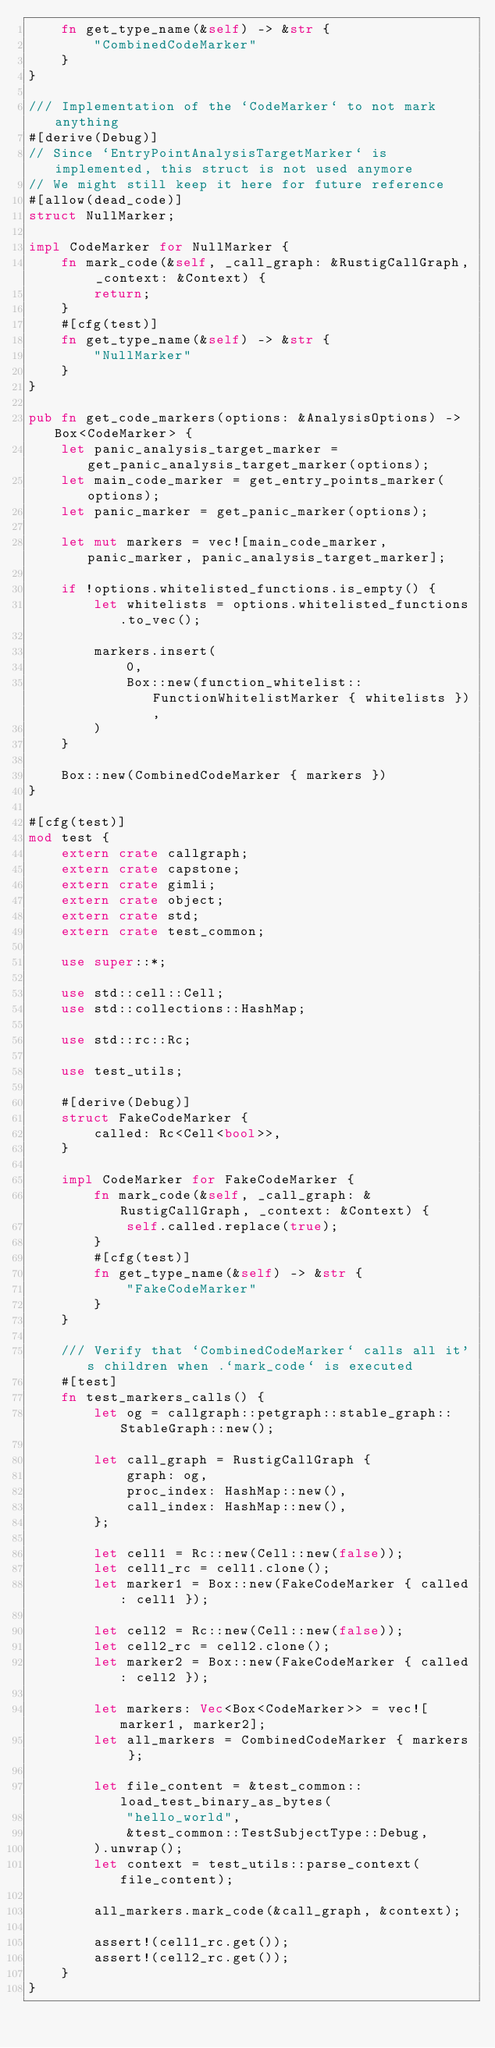<code> <loc_0><loc_0><loc_500><loc_500><_Rust_>    fn get_type_name(&self) -> &str {
        "CombinedCodeMarker"
    }
}

/// Implementation of the `CodeMarker` to not mark anything
#[derive(Debug)]
// Since `EntryPointAnalysisTargetMarker` is implemented, this struct is not used anymore
// We might still keep it here for future reference
#[allow(dead_code)]
struct NullMarker;

impl CodeMarker for NullMarker {
    fn mark_code(&self, _call_graph: &RustigCallGraph, _context: &Context) {
        return;
    }
    #[cfg(test)]
    fn get_type_name(&self) -> &str {
        "NullMarker"
    }
}

pub fn get_code_markers(options: &AnalysisOptions) -> Box<CodeMarker> {
    let panic_analysis_target_marker = get_panic_analysis_target_marker(options);
    let main_code_marker = get_entry_points_marker(options);
    let panic_marker = get_panic_marker(options);

    let mut markers = vec![main_code_marker, panic_marker, panic_analysis_target_marker];

    if !options.whitelisted_functions.is_empty() {
        let whitelists = options.whitelisted_functions.to_vec();

        markers.insert(
            0,
            Box::new(function_whitelist::FunctionWhitelistMarker { whitelists }),
        )
    }

    Box::new(CombinedCodeMarker { markers })
}

#[cfg(test)]
mod test {
    extern crate callgraph;
    extern crate capstone;
    extern crate gimli;
    extern crate object;
    extern crate std;
    extern crate test_common;

    use super::*;

    use std::cell::Cell;
    use std::collections::HashMap;

    use std::rc::Rc;

    use test_utils;

    #[derive(Debug)]
    struct FakeCodeMarker {
        called: Rc<Cell<bool>>,
    }

    impl CodeMarker for FakeCodeMarker {
        fn mark_code(&self, _call_graph: &RustigCallGraph, _context: &Context) {
            self.called.replace(true);
        }
        #[cfg(test)]
        fn get_type_name(&self) -> &str {
            "FakeCodeMarker"
        }
    }

    /// Verify that `CombinedCodeMarker` calls all it's children when .`mark_code` is executed
    #[test]
    fn test_markers_calls() {
        let og = callgraph::petgraph::stable_graph::StableGraph::new();

        let call_graph = RustigCallGraph {
            graph: og,
            proc_index: HashMap::new(),
            call_index: HashMap::new(),
        };

        let cell1 = Rc::new(Cell::new(false));
        let cell1_rc = cell1.clone();
        let marker1 = Box::new(FakeCodeMarker { called: cell1 });

        let cell2 = Rc::new(Cell::new(false));
        let cell2_rc = cell2.clone();
        let marker2 = Box::new(FakeCodeMarker { called: cell2 });

        let markers: Vec<Box<CodeMarker>> = vec![marker1, marker2];
        let all_markers = CombinedCodeMarker { markers };

        let file_content = &test_common::load_test_binary_as_bytes(
            "hello_world",
            &test_common::TestSubjectType::Debug,
        ).unwrap();
        let context = test_utils::parse_context(file_content);

        all_markers.mark_code(&call_graph, &context);

        assert!(cell1_rc.get());
        assert!(cell2_rc.get());
    }
}
</code> 